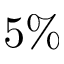<formula> <loc_0><loc_0><loc_500><loc_500>5 \%</formula> 